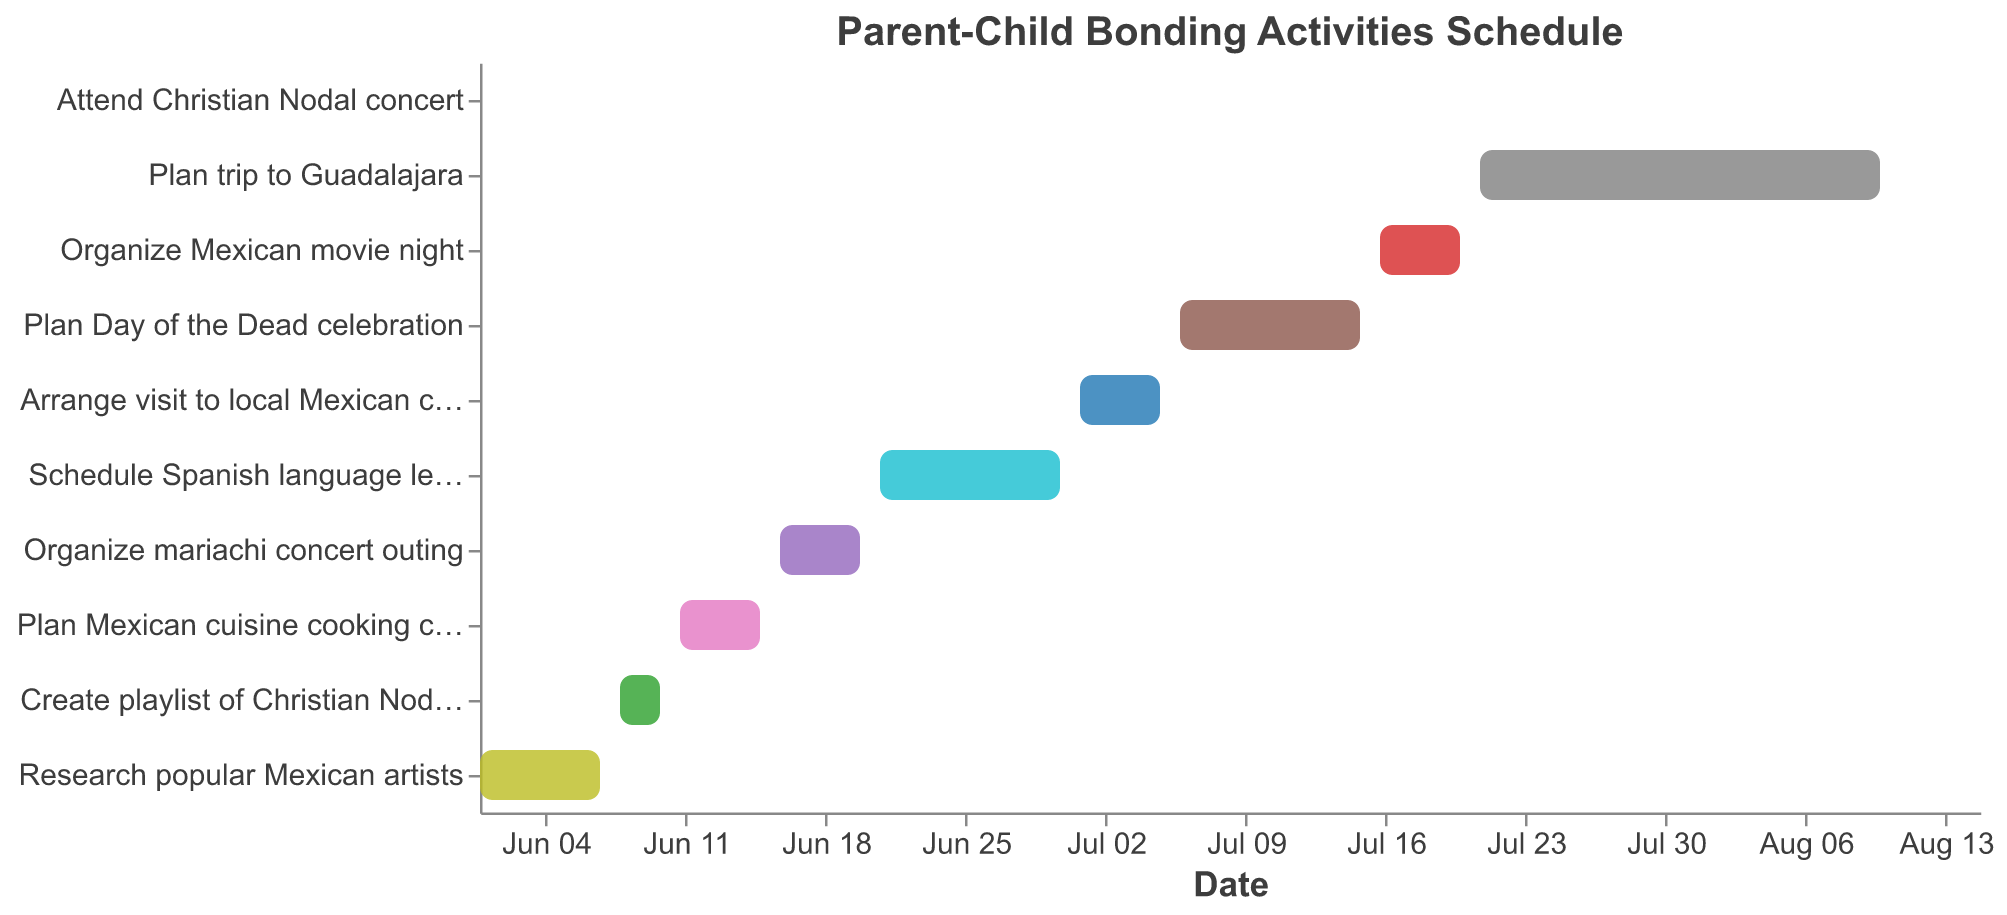What is the title of the chart? The title of the chart is displayed at the top of the figure.
Answer: Parent-Child Bonding Activities Schedule What activity is scheduled to start on June 11? Locate June 11 on the x-axis and see which task starts on that date.
Answer: Plan Mexican cuisine cooking class Which task lasts the longest? Compare the duration (difference between start and end dates) of all tasks to identify the longest one.
Answer: Plan trip to Guadalajara How many days are scheduled for Spanish language lessons? Find the start and end dates for "Schedule Spanish language lessons" and calculate the difference.
Answer: 10 days Which activity ends on July 20? Look for the task that has "July 20" as its end date.
Answer: Organize Mexican movie night Which tasks overlap in their timelines? Identify tasks whose date ranges overlap on the x-axis.
Answer: Plan Day of the Dead celebration and Organize Mexican movie night What is the time gap between planning a mariachi concert outing and scheduling Spanish language lessons? Calculate the number of days between the end date of "Organize mariachi concert outing" and the start date of "Schedule Spanish language lessons".
Answer: 1 day When is the first activity scheduled to begin and the last activity scheduled to end? Look at the start date of the first task and the end date of the last task.
Answer: June 1 and August 15 Which activity has the same start and end date? Find the task where the start date equals the end date.
Answer: Attend Christian Nodal concert 